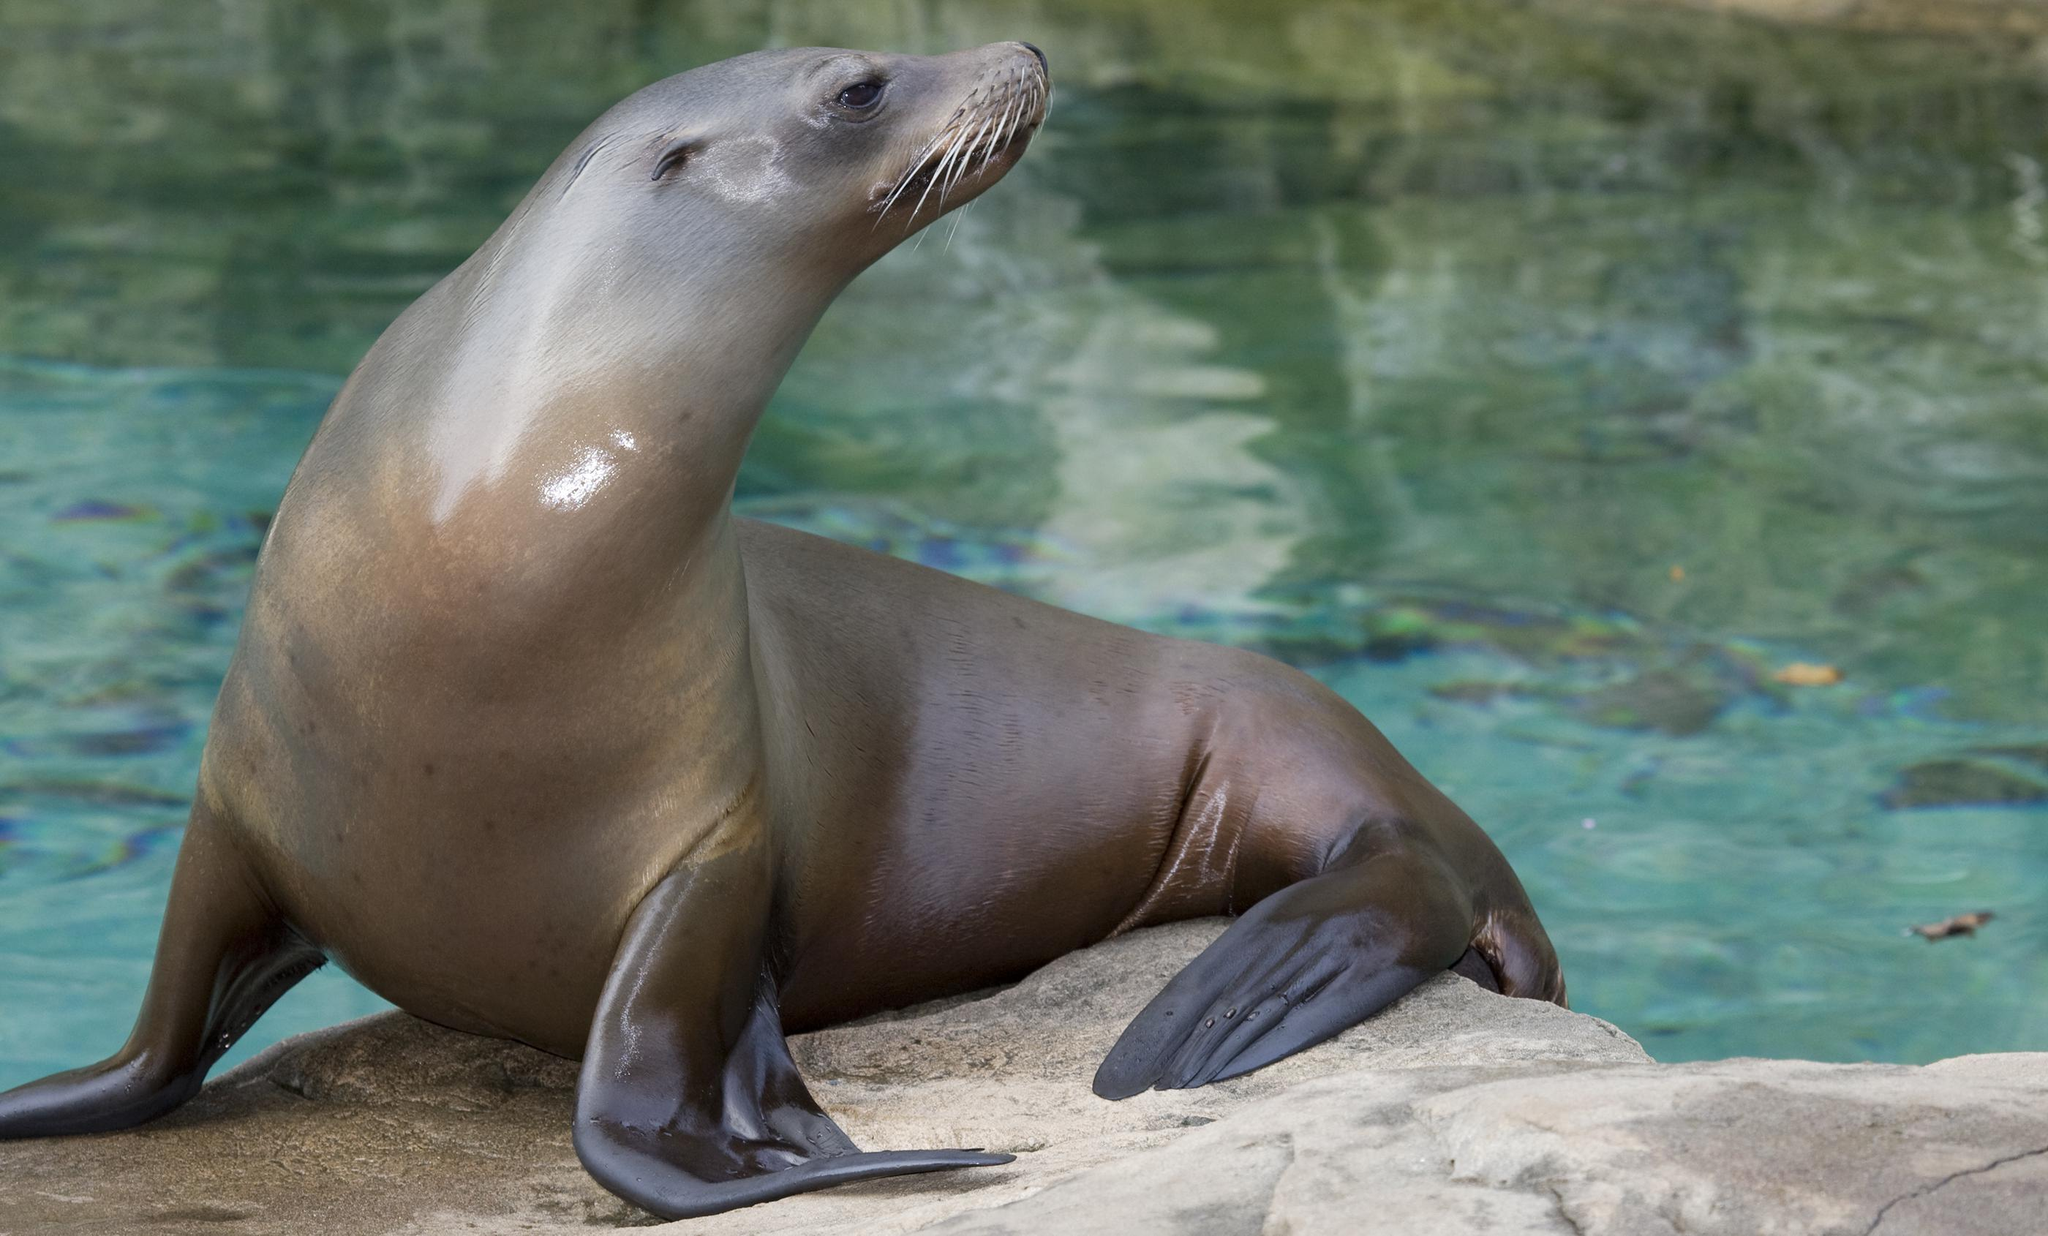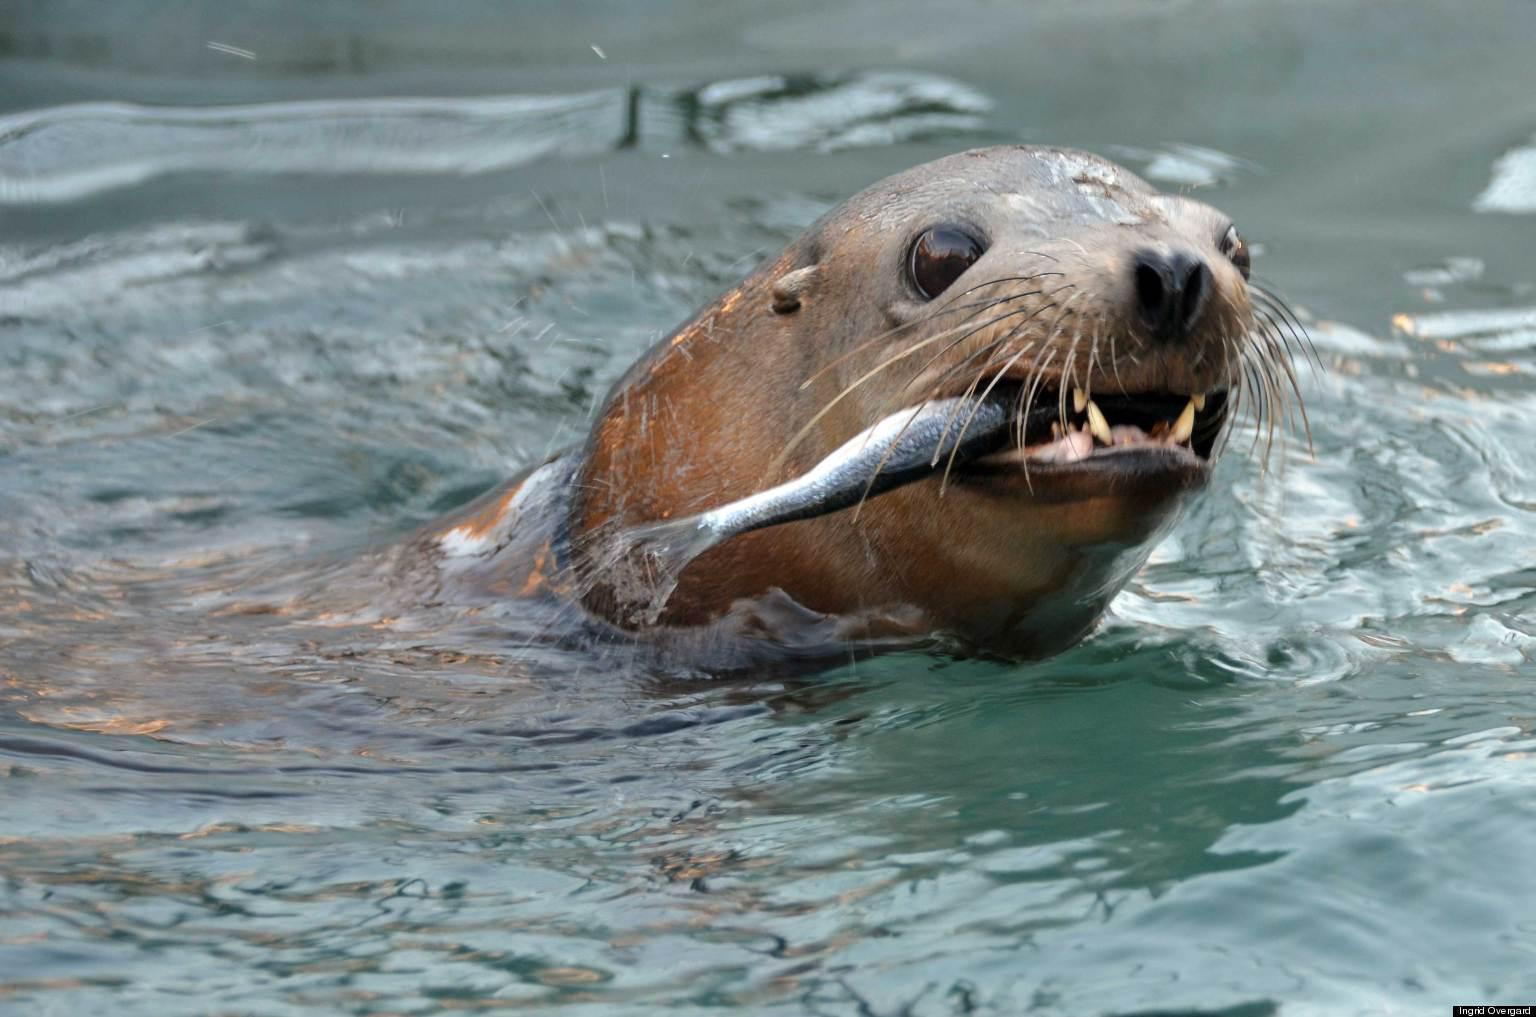The first image is the image on the left, the second image is the image on the right. Evaluate the accuracy of this statement regarding the images: "Atleast one image of a seal eating an octopus". Is it true? Answer yes or no. No. The first image is the image on the left, the second image is the image on the right. Considering the images on both sides, is "At least one image shows a sea lion with octopus tentacles in its mouth." valid? Answer yes or no. No. 